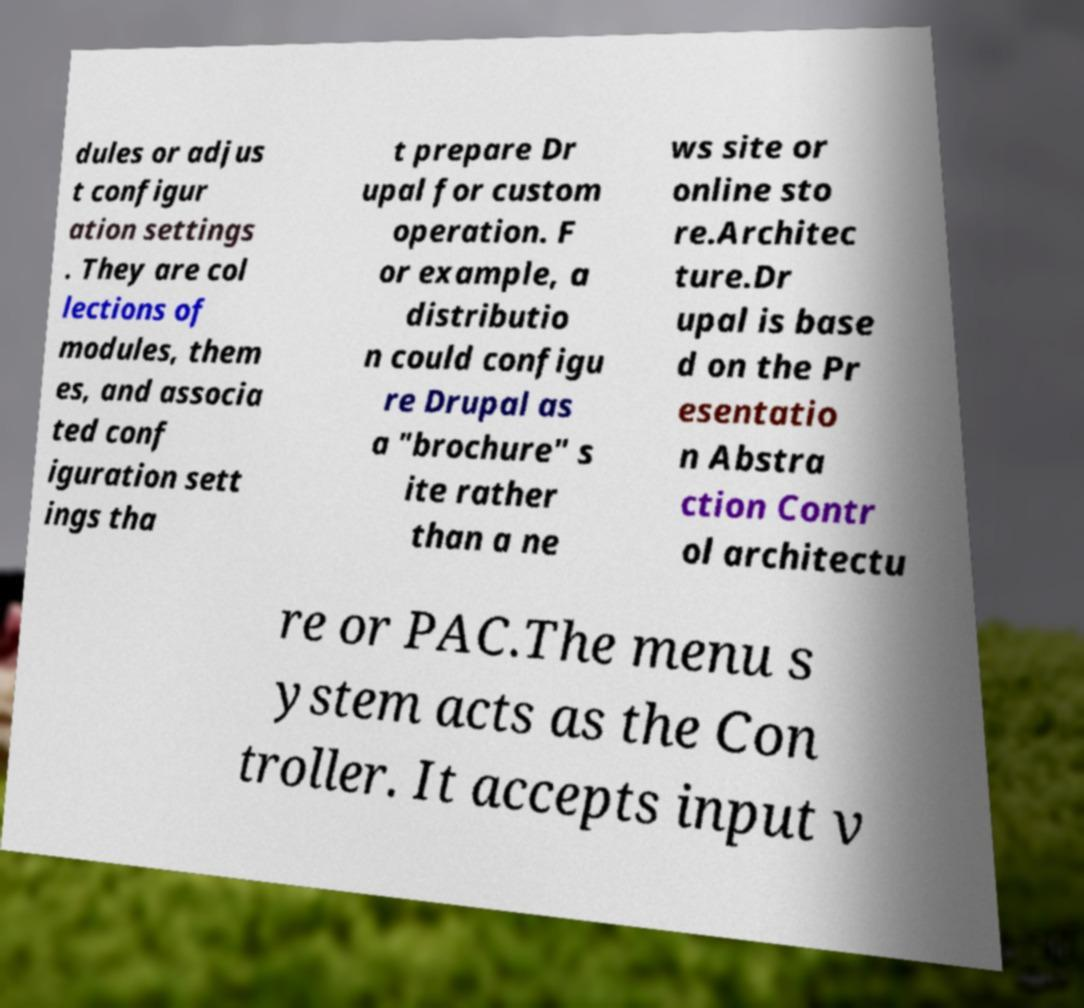Could you extract and type out the text from this image? dules or adjus t configur ation settings . They are col lections of modules, them es, and associa ted conf iguration sett ings tha t prepare Dr upal for custom operation. F or example, a distributio n could configu re Drupal as a "brochure" s ite rather than a ne ws site or online sto re.Architec ture.Dr upal is base d on the Pr esentatio n Abstra ction Contr ol architectu re or PAC.The menu s ystem acts as the Con troller. It accepts input v 